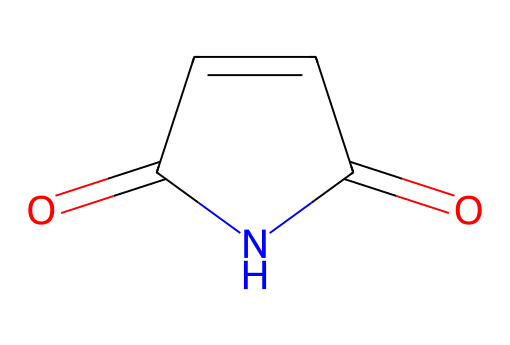How many carbon atoms are in maleimide? By analyzing the SMILES representation O=C1C=CC(=O)N1, we can count the carbon (C) symbols. There are three carbon atoms visible in the main structure, including those involved in double bonds and part of the rings.
Answer: 3 What functional groups are present in maleimide? The SMILES representation indicates the presence of a carbonyl group (C=O) and an imide group (C1C=CC(=O)N1). The first carbonyl indicates an imide structure, along with the adjacent nitrogen.
Answer: carbonyl, imide How many rings does maleimide contain? The 'C1' in the SMILES notation indicates the start of a ring, and the corresponding '1' later in the structure closes it. This suggests that there is one cyclic structure present.
Answer: 1 What is the molecular formula of maleimide? To derive the molecular formula, we tally the elements from the SMILES representation: 4 carbon (C), 3 hydrogen (H), 1 nitrogen (N), and 2 oxygen (O), resulting in C4H3N1O2.
Answer: C4H3N1O2 What type of reaction is maleimide commonly involved in during polymer synthesis? Maleimide often participates in Michael addition reactions, where it acts as an electrophile to form covalent bonds with nucleophiles during polymer synthesis and bioconjugation.
Answer: Michael addition How does the presence of the nitrogen in maleimide influence its reactivity? The nitrogen in the imide group enhances the electrophilic nature of the carbonyl carbons, making maleimide more reactive towards nucleophiles, which is crucial for its role in bioconjugation.
Answer: increases reactivity What is a common application of maleimide in bioconjugation? Maleimide is widely used to form stable thioether bonds with thiols (such as cysteine residues in proteins), enabling the conjugation of biomolecules in therapeutic and diagnostic applications.
Answer: conjugation of biomolecules 